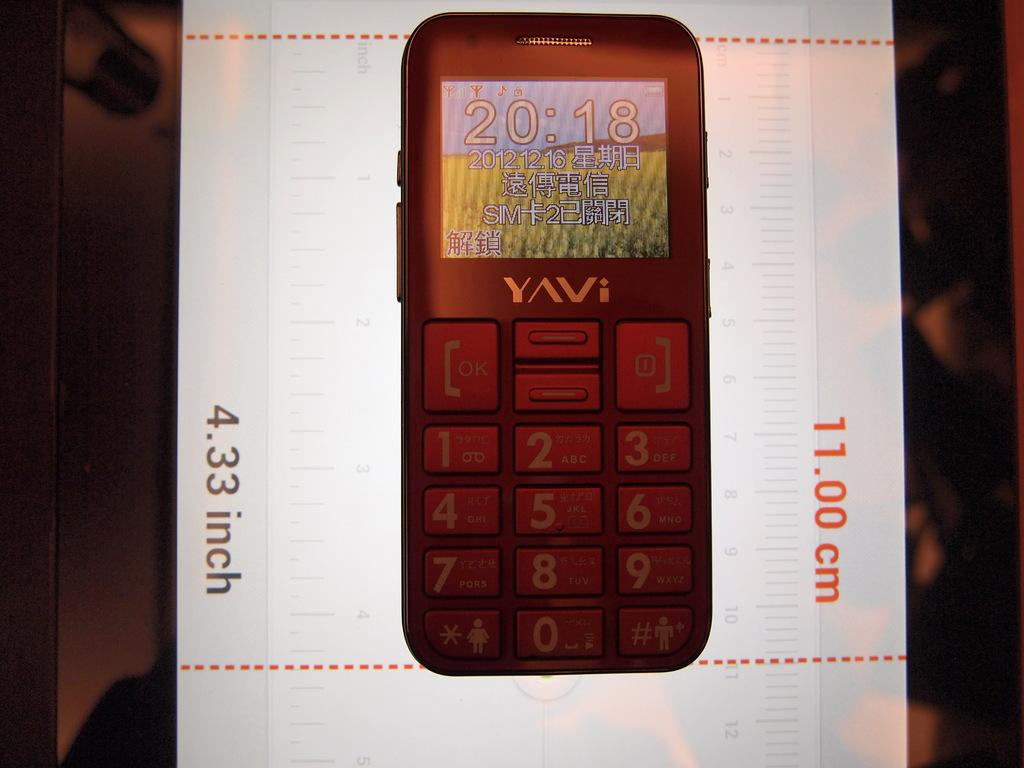<image>
Describe the image concisely. A YAVi cellphone is shown to be 11.00 cm long. 